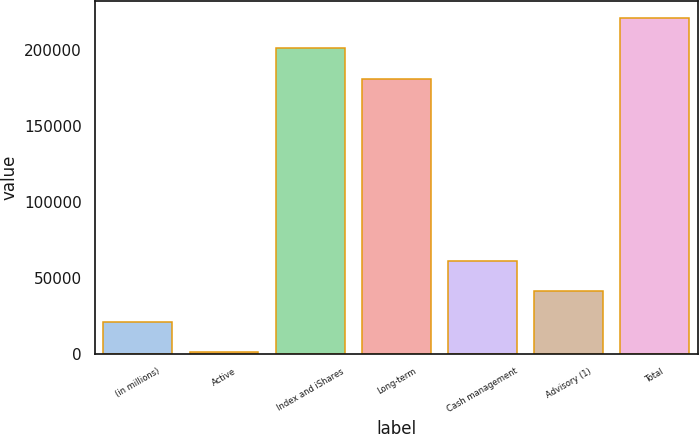<chart> <loc_0><loc_0><loc_500><loc_500><bar_chart><fcel>(in millions)<fcel>Active<fcel>Index and iShares<fcel>Long-term<fcel>Cash management<fcel>Advisory (1)<fcel>Total<nl><fcel>20915.7<fcel>774<fcel>200706<fcel>180564<fcel>61199.1<fcel>41057.4<fcel>220847<nl></chart> 